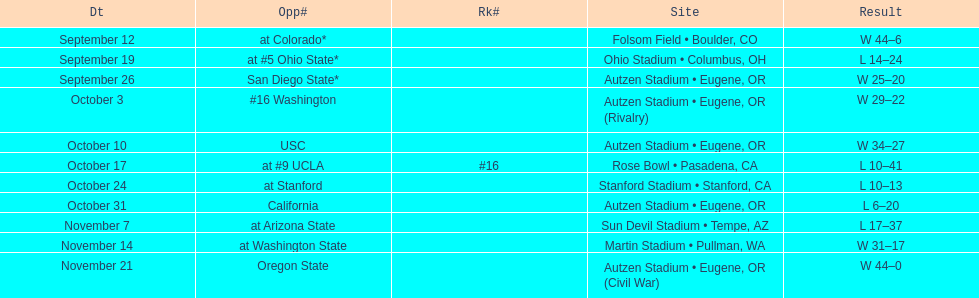Which bowl game did the university of oregon ducks football team play in during the 1987 season? Rose Bowl. 